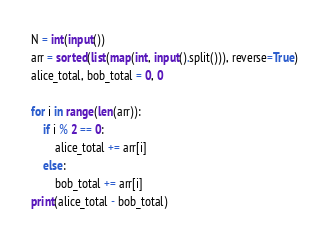<code> <loc_0><loc_0><loc_500><loc_500><_Python_>N = int(input())
arr = sorted(list(map(int, input().split())), reverse=True)
alice_total, bob_total = 0, 0

for i in range(len(arr)):
    if i % 2 == 0:
        alice_total += arr[i]
    else:
        bob_total += arr[i]
print(alice_total - bob_total)
</code> 